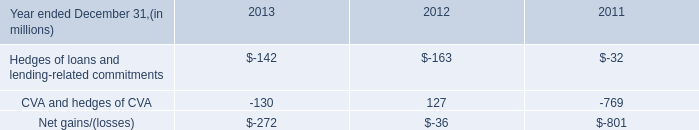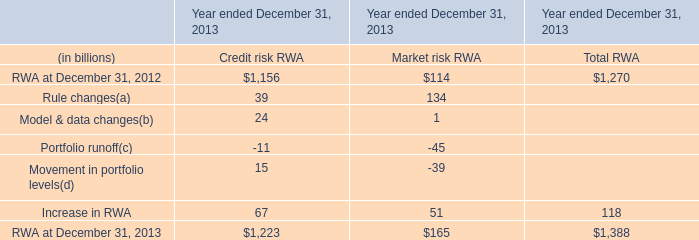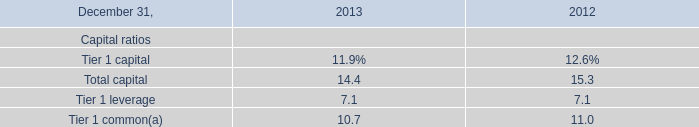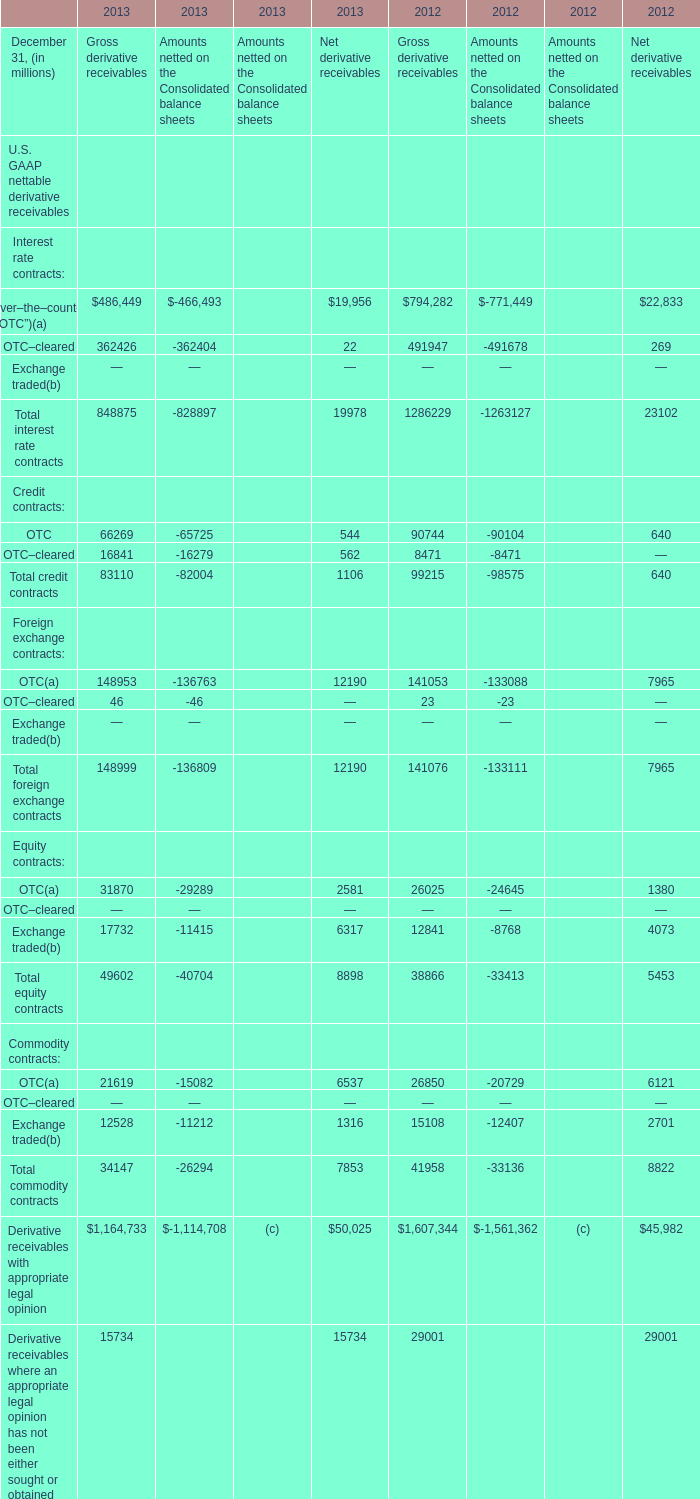When is total interest rate contracts of Net derivative receivables the largest? 
Answer: 2012. 